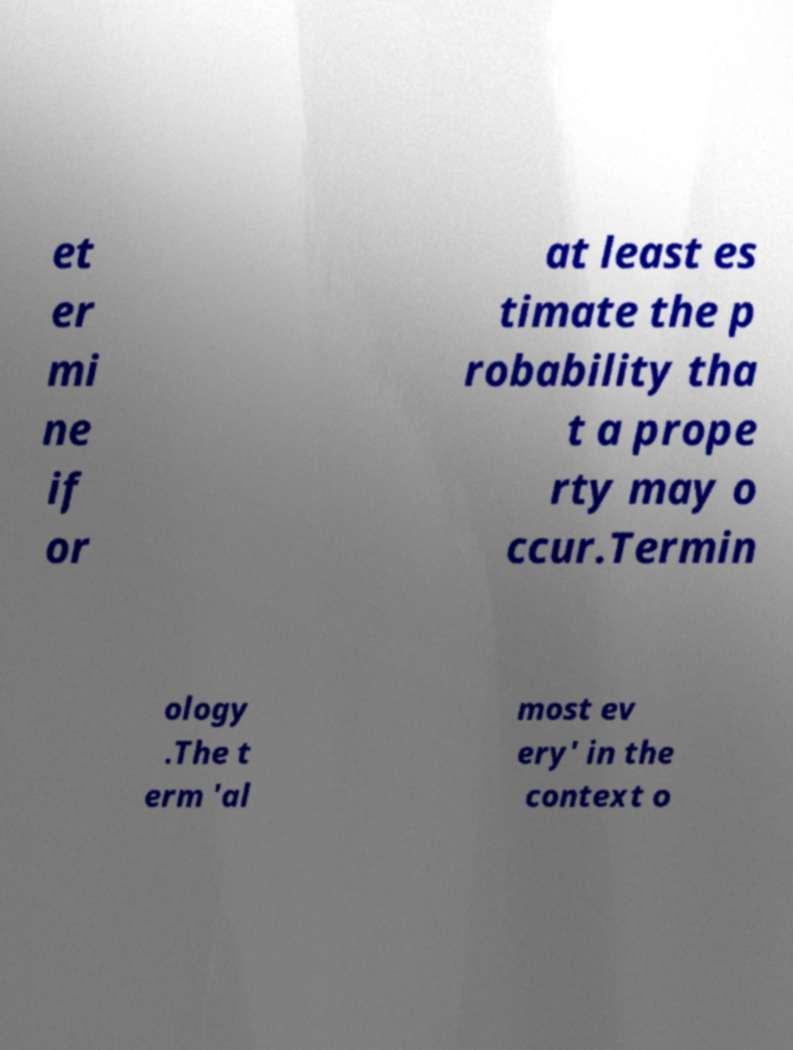What messages or text are displayed in this image? I need them in a readable, typed format. et er mi ne if or at least es timate the p robability tha t a prope rty may o ccur.Termin ology .The t erm 'al most ev ery' in the context o 